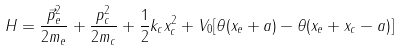<formula> <loc_0><loc_0><loc_500><loc_500>H = \frac { \vec { p } _ { e } ^ { 2 } } { 2 m _ { e } } + \frac { p _ { c } ^ { 2 } } { 2 m _ { c } } + \frac { 1 } { 2 } k _ { c } x _ { c } ^ { 2 } + V _ { 0 } [ \theta ( x _ { e } + a ) - \theta ( x _ { e } + x _ { c } - a ) ] \text { }</formula> 